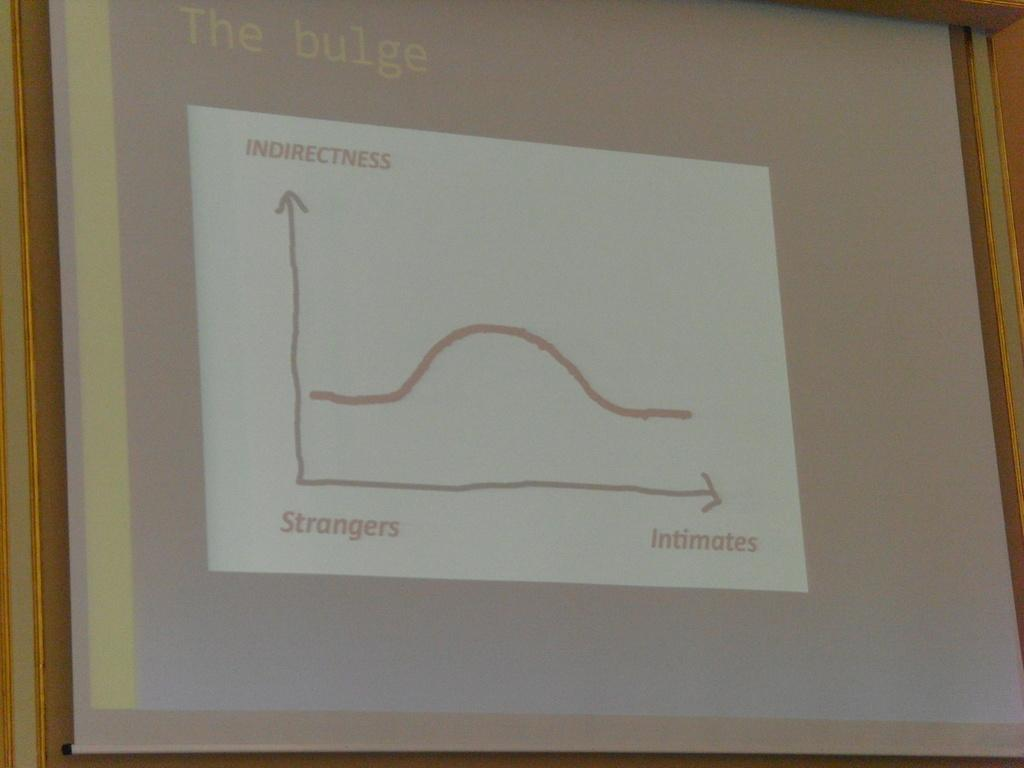<image>
Share a concise interpretation of the image provided. A projector screen shows a graph of the relationship between indirectness and how well you know someone. 